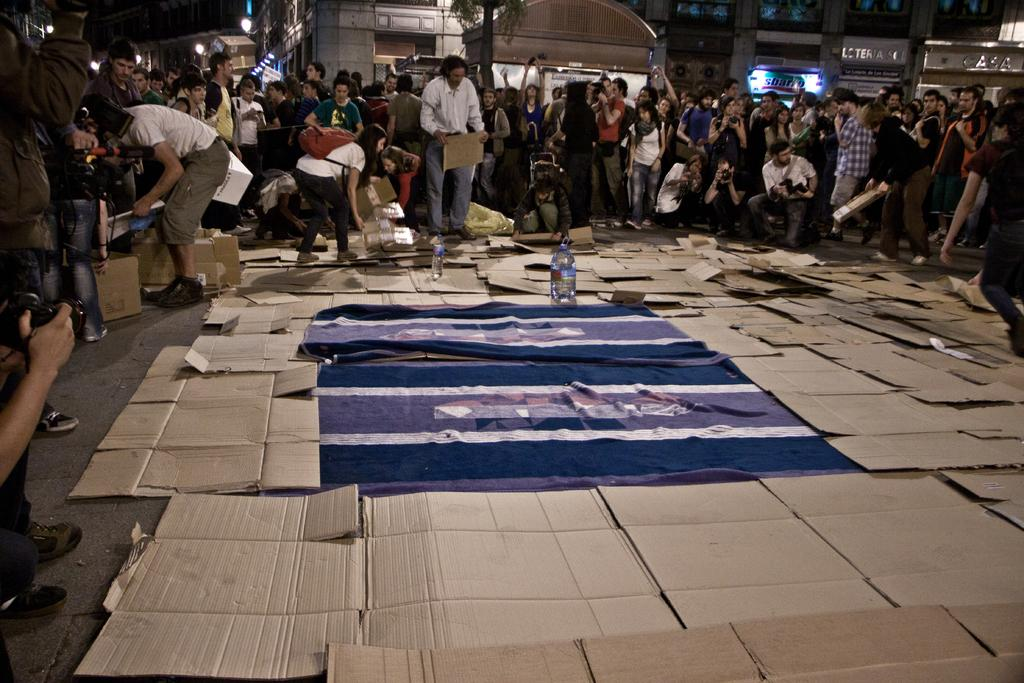What is located in the center of the image? There are bed sheets and boards placed on the ground in the center of the image. Can you describe the background of the image? There are persons, buildings, trees, and lights visible in the background of the image. What type of brush can be seen in the image? There is no brush present in the image. What songs are being sung by the persons in the background of the image? There is no indication of any songs being sung in the image; only the presence of persons, buildings, trees, and lights is mentioned. 